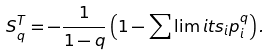Convert formula to latex. <formula><loc_0><loc_0><loc_500><loc_500>S _ { q } ^ { T } = - \frac { 1 } { 1 - q } \left ( 1 - \sum \lim i t s _ { i } p _ { i } ^ { q } \right ) .</formula> 